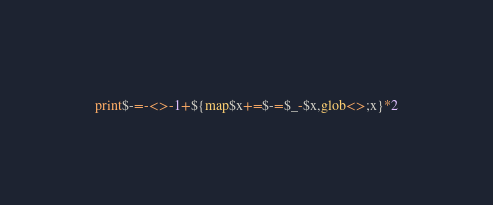<code> <loc_0><loc_0><loc_500><loc_500><_Perl_>print$-=-<>-1+${map$x+=$-=$_-$x,glob<>;x}*2</code> 